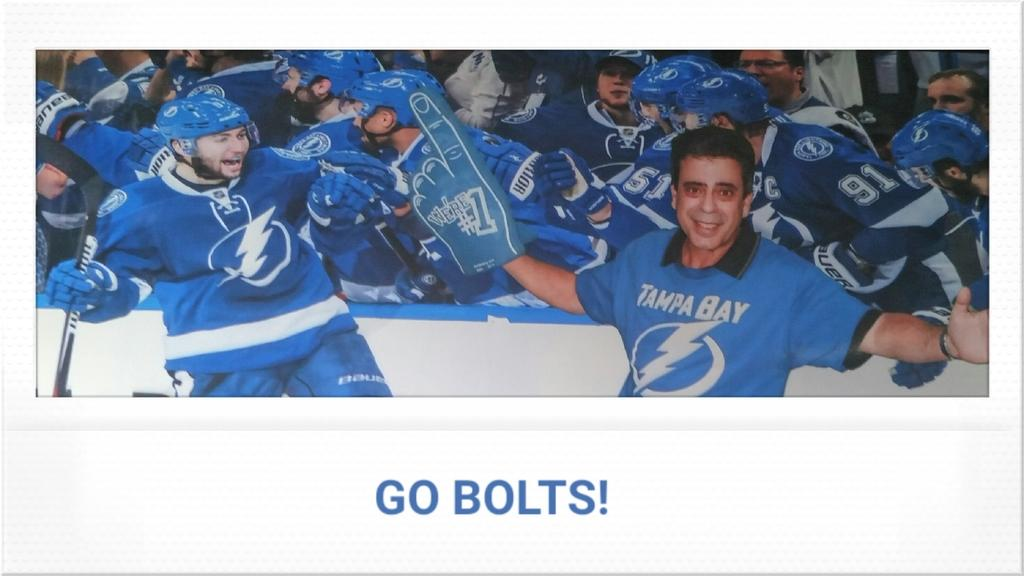<image>
Provide a brief description of the given image. Photo of a hockey team celebrating and the words "Go Bolts" on the bottom. 